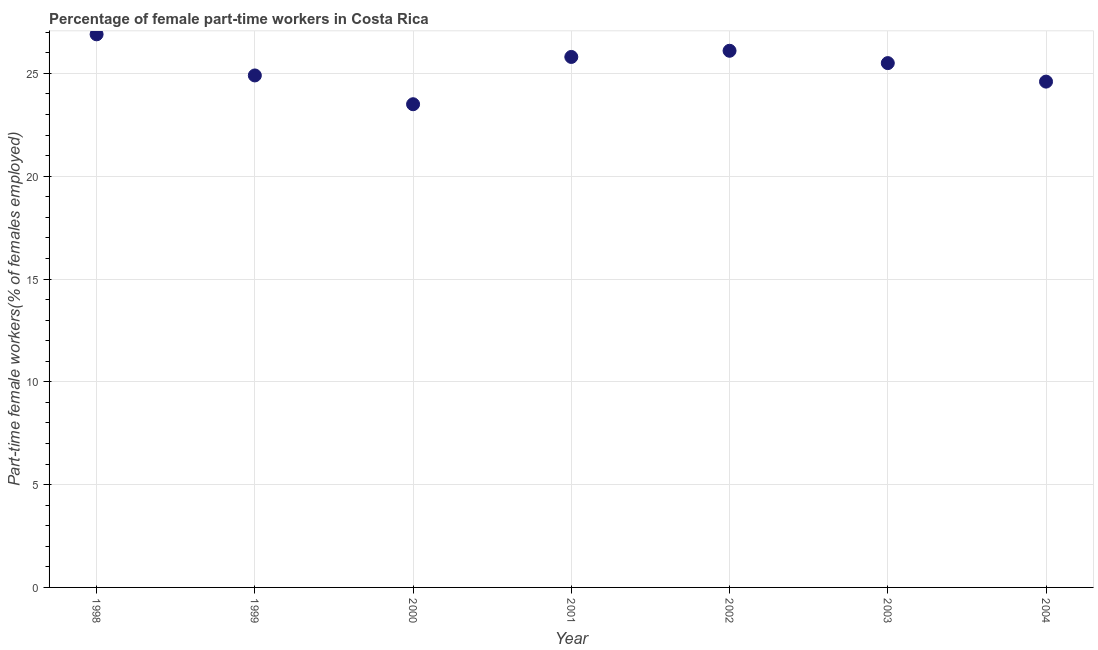What is the percentage of part-time female workers in 1999?
Your response must be concise. 24.9. Across all years, what is the maximum percentage of part-time female workers?
Offer a terse response. 26.9. Across all years, what is the minimum percentage of part-time female workers?
Make the answer very short. 23.5. What is the sum of the percentage of part-time female workers?
Offer a terse response. 177.3. What is the difference between the percentage of part-time female workers in 2003 and 2004?
Your answer should be compact. 0.9. What is the average percentage of part-time female workers per year?
Your response must be concise. 25.33. What is the median percentage of part-time female workers?
Offer a terse response. 25.5. Do a majority of the years between 2001 and 1999 (inclusive) have percentage of part-time female workers greater than 26 %?
Make the answer very short. No. What is the ratio of the percentage of part-time female workers in 1998 to that in 2002?
Your answer should be compact. 1.03. Is the percentage of part-time female workers in 1998 less than that in 2000?
Provide a short and direct response. No. What is the difference between the highest and the second highest percentage of part-time female workers?
Keep it short and to the point. 0.8. Is the sum of the percentage of part-time female workers in 2000 and 2004 greater than the maximum percentage of part-time female workers across all years?
Offer a terse response. Yes. What is the difference between the highest and the lowest percentage of part-time female workers?
Ensure brevity in your answer.  3.4. In how many years, is the percentage of part-time female workers greater than the average percentage of part-time female workers taken over all years?
Make the answer very short. 4. How many dotlines are there?
Keep it short and to the point. 1. How many years are there in the graph?
Offer a terse response. 7. What is the difference between two consecutive major ticks on the Y-axis?
Your answer should be very brief. 5. Are the values on the major ticks of Y-axis written in scientific E-notation?
Your answer should be compact. No. Does the graph contain any zero values?
Your response must be concise. No. Does the graph contain grids?
Your answer should be compact. Yes. What is the title of the graph?
Your response must be concise. Percentage of female part-time workers in Costa Rica. What is the label or title of the Y-axis?
Make the answer very short. Part-time female workers(% of females employed). What is the Part-time female workers(% of females employed) in 1998?
Keep it short and to the point. 26.9. What is the Part-time female workers(% of females employed) in 1999?
Provide a short and direct response. 24.9. What is the Part-time female workers(% of females employed) in 2001?
Your answer should be compact. 25.8. What is the Part-time female workers(% of females employed) in 2002?
Offer a very short reply. 26.1. What is the Part-time female workers(% of females employed) in 2004?
Ensure brevity in your answer.  24.6. What is the difference between the Part-time female workers(% of females employed) in 1998 and 1999?
Make the answer very short. 2. What is the difference between the Part-time female workers(% of females employed) in 1998 and 2000?
Offer a terse response. 3.4. What is the difference between the Part-time female workers(% of females employed) in 1998 and 2001?
Give a very brief answer. 1.1. What is the difference between the Part-time female workers(% of females employed) in 1999 and 2000?
Offer a terse response. 1.4. What is the difference between the Part-time female workers(% of females employed) in 1999 and 2002?
Offer a terse response. -1.2. What is the difference between the Part-time female workers(% of females employed) in 1999 and 2004?
Offer a terse response. 0.3. What is the difference between the Part-time female workers(% of females employed) in 2000 and 2002?
Give a very brief answer. -2.6. What is the difference between the Part-time female workers(% of females employed) in 2000 and 2003?
Your response must be concise. -2. What is the difference between the Part-time female workers(% of females employed) in 2001 and 2002?
Make the answer very short. -0.3. What is the difference between the Part-time female workers(% of females employed) in 2001 and 2003?
Provide a short and direct response. 0.3. What is the difference between the Part-time female workers(% of females employed) in 2001 and 2004?
Make the answer very short. 1.2. What is the difference between the Part-time female workers(% of females employed) in 2002 and 2003?
Offer a very short reply. 0.6. What is the ratio of the Part-time female workers(% of females employed) in 1998 to that in 1999?
Ensure brevity in your answer.  1.08. What is the ratio of the Part-time female workers(% of females employed) in 1998 to that in 2000?
Keep it short and to the point. 1.15. What is the ratio of the Part-time female workers(% of females employed) in 1998 to that in 2001?
Provide a short and direct response. 1.04. What is the ratio of the Part-time female workers(% of females employed) in 1998 to that in 2002?
Give a very brief answer. 1.03. What is the ratio of the Part-time female workers(% of females employed) in 1998 to that in 2003?
Make the answer very short. 1.05. What is the ratio of the Part-time female workers(% of females employed) in 1998 to that in 2004?
Give a very brief answer. 1.09. What is the ratio of the Part-time female workers(% of females employed) in 1999 to that in 2000?
Make the answer very short. 1.06. What is the ratio of the Part-time female workers(% of females employed) in 1999 to that in 2002?
Offer a very short reply. 0.95. What is the ratio of the Part-time female workers(% of females employed) in 1999 to that in 2004?
Your answer should be compact. 1.01. What is the ratio of the Part-time female workers(% of females employed) in 2000 to that in 2001?
Your answer should be compact. 0.91. What is the ratio of the Part-time female workers(% of females employed) in 2000 to that in 2003?
Provide a short and direct response. 0.92. What is the ratio of the Part-time female workers(% of females employed) in 2000 to that in 2004?
Ensure brevity in your answer.  0.95. What is the ratio of the Part-time female workers(% of females employed) in 2001 to that in 2003?
Give a very brief answer. 1.01. What is the ratio of the Part-time female workers(% of females employed) in 2001 to that in 2004?
Provide a short and direct response. 1.05. What is the ratio of the Part-time female workers(% of females employed) in 2002 to that in 2004?
Provide a succinct answer. 1.06. 